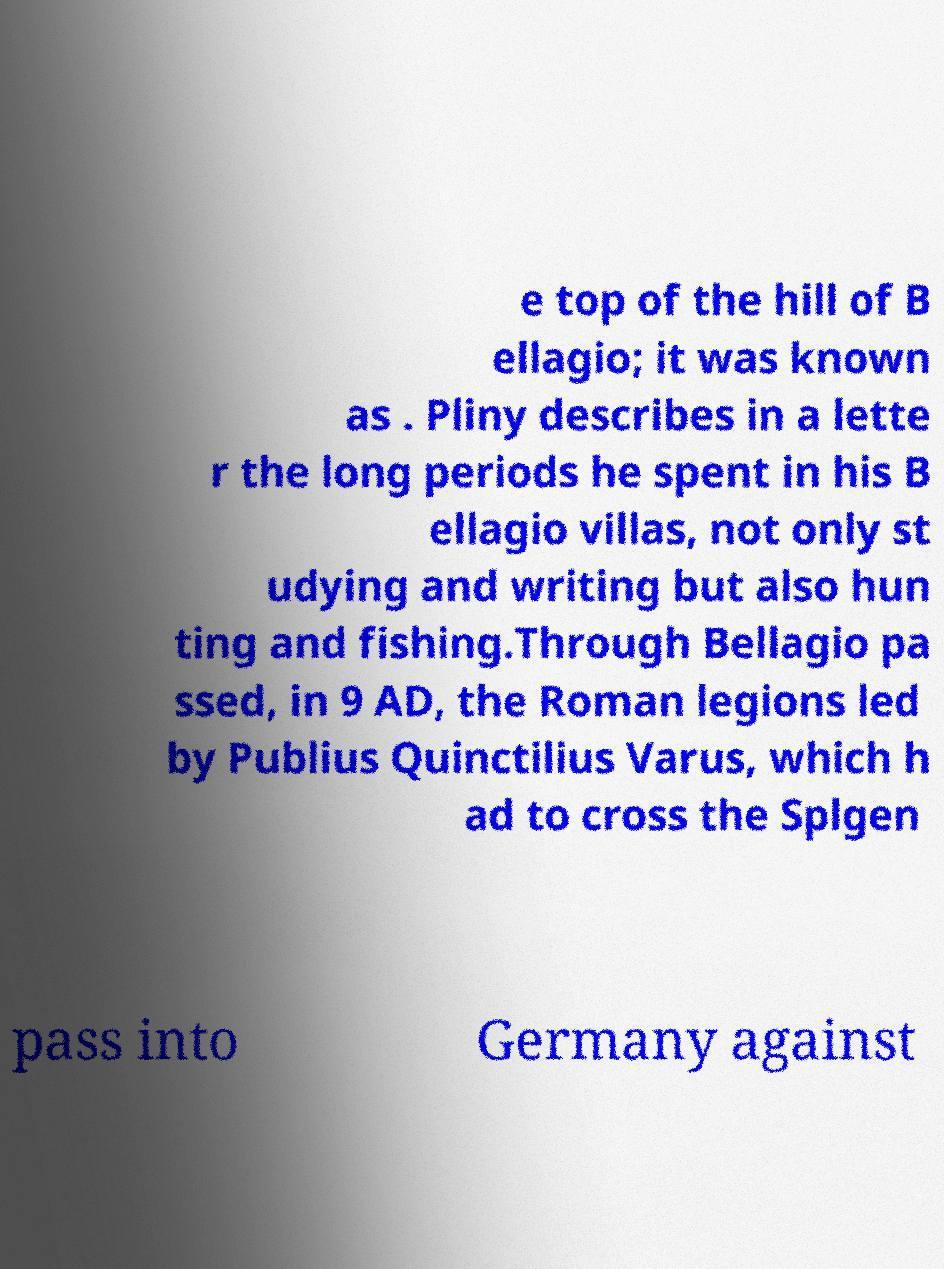I need the written content from this picture converted into text. Can you do that? e top of the hill of B ellagio; it was known as . Pliny describes in a lette r the long periods he spent in his B ellagio villas, not only st udying and writing but also hun ting and fishing.Through Bellagio pa ssed, in 9 AD, the Roman legions led by Publius Quinctilius Varus, which h ad to cross the Splgen pass into Germany against 